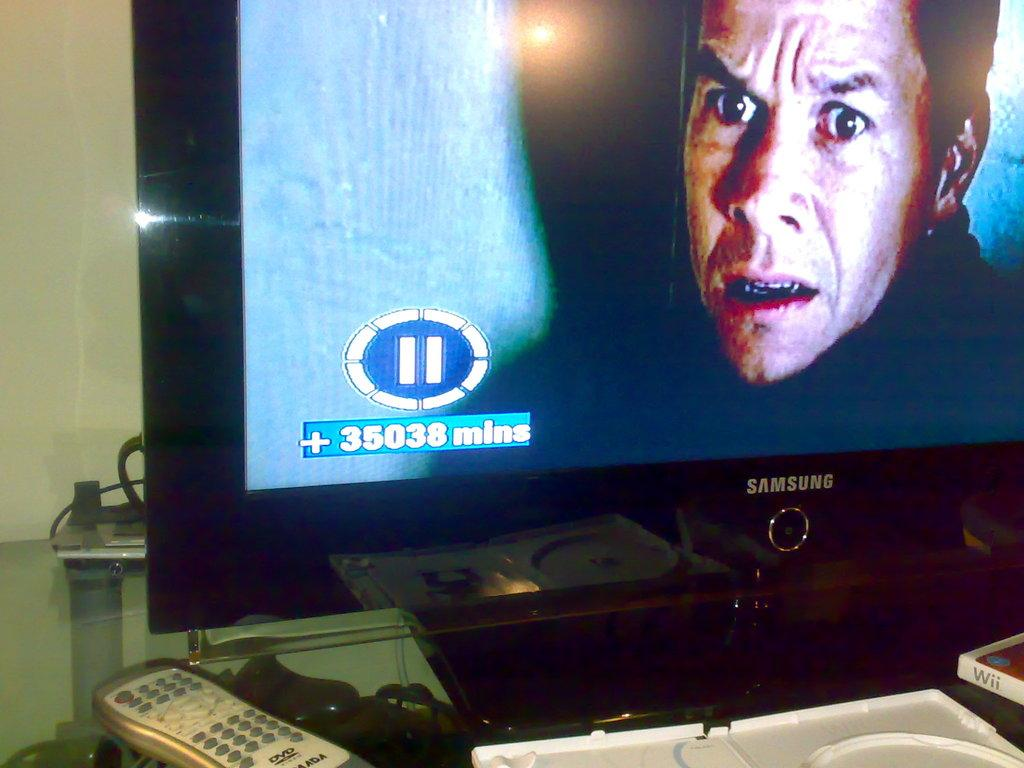<image>
Offer a succinct explanation of the picture presented. a samsung flat screen tv with a pause screen 